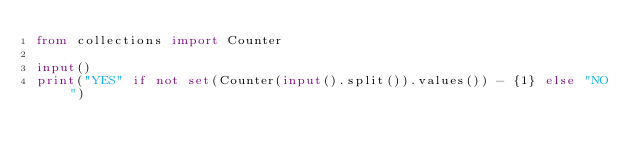<code> <loc_0><loc_0><loc_500><loc_500><_Python_>from collections import Counter

input()
print("YES" if not set(Counter(input().split()).values()) - {1} else "NO")
</code> 